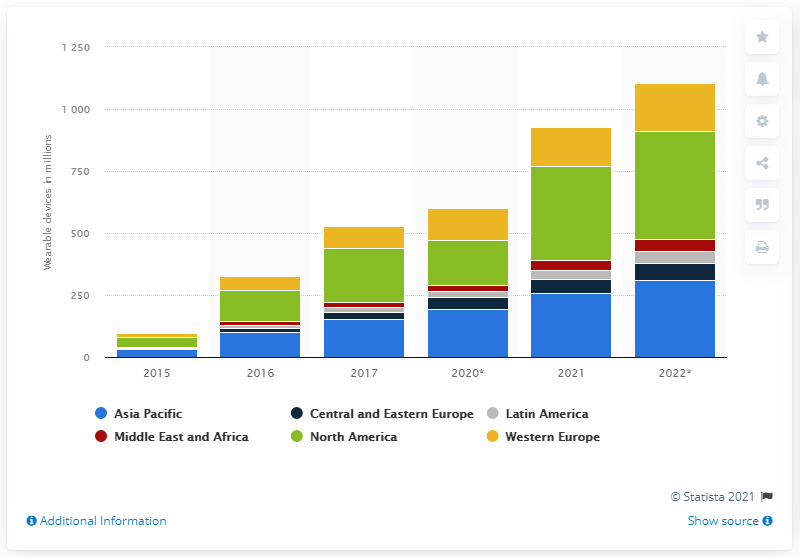Indicate a few pertinent items in this graphic. It is expected that by 2022, there will be 439 5G connections made in North America. 